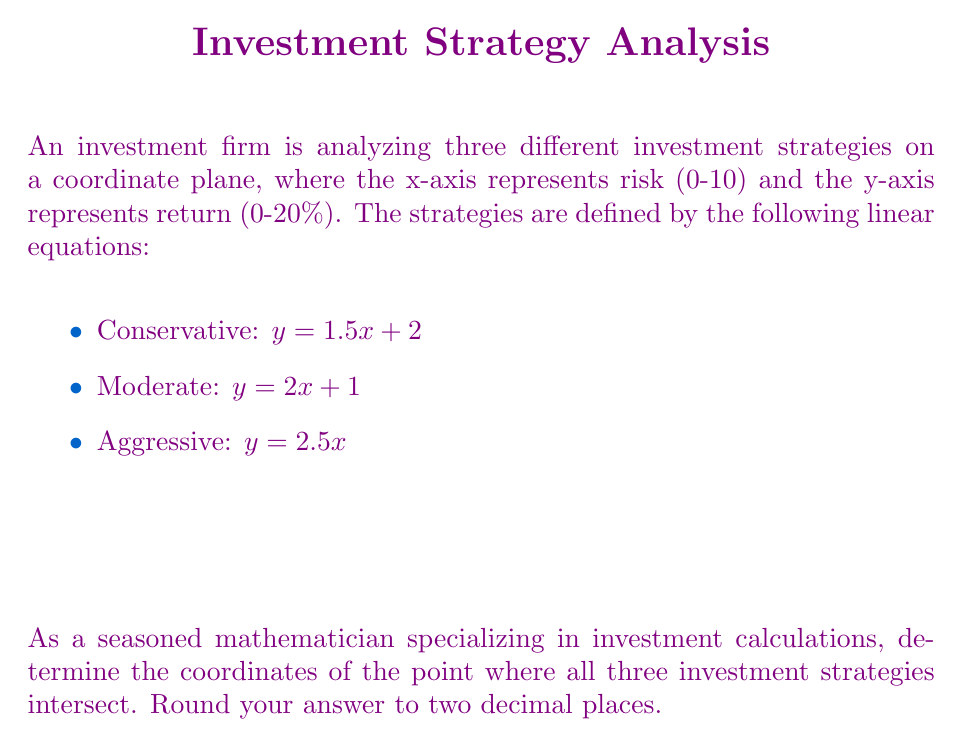What is the answer to this math problem? To find the intersection point of all three strategies, we need to solve the system of equations:

1. $y = 1.5x + 2$
2. $y = 2x + 1$
3. $y = 2.5x$

Step 1: Equate equations 1 and 2:
$1.5x + 2 = 2x + 1$
$2 - 1 = 2x - 1.5x$
$1 = 0.5x$
$x = 2$

Step 2: Substitute $x = 2$ into equation 1 to find $y$:
$y = 1.5(2) + 2 = 3 + 2 = 5$

Step 3: Verify that the point $(2, 5)$ satisfies equation 3:
$y = 2.5x$
$5 = 2.5(2)$
$5 = 5$ (equation holds)

Step 4: Round the coordinates to two decimal places:
$x = 2.00$
$y = 5.00$

Therefore, the point of intersection for all three investment strategies is $(2.00, 5.00)$.
Answer: $(2.00, 5.00)$ 